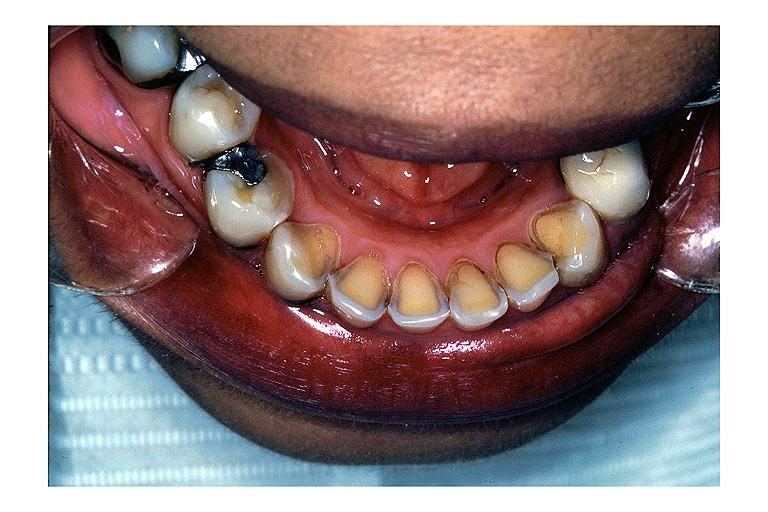s oral present?
Answer the question using a single word or phrase. Yes 